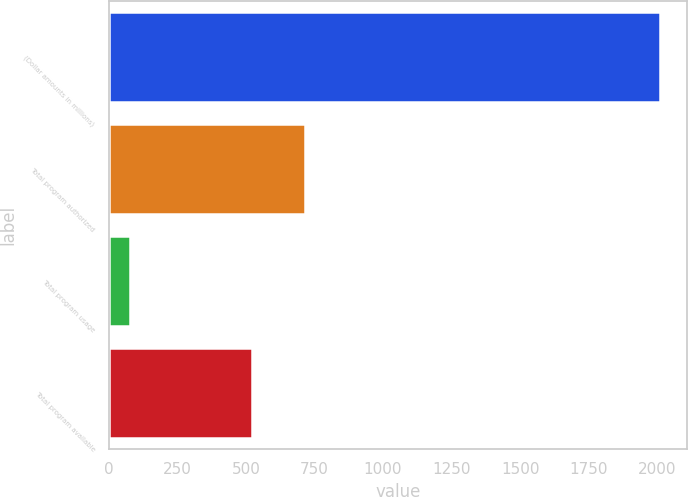Convert chart to OTSL. <chart><loc_0><loc_0><loc_500><loc_500><bar_chart><fcel>(Dollar amounts in millions)<fcel>Total program authorized<fcel>Total program usage<fcel>Total program available<nl><fcel>2010<fcel>715.2<fcel>78<fcel>522<nl></chart> 